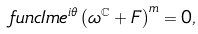Convert formula to latex. <formula><loc_0><loc_0><loc_500><loc_500>\ f u n c { I m } e ^ { i \theta } \left ( \omega ^ { \mathbb { C } } + F \right ) ^ { m } = 0 ,</formula> 